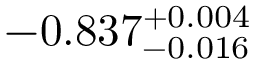<formula> <loc_0><loc_0><loc_500><loc_500>- 0 . 8 3 7 _ { - 0 . 0 1 6 } ^ { + 0 . 0 0 4 }</formula> 